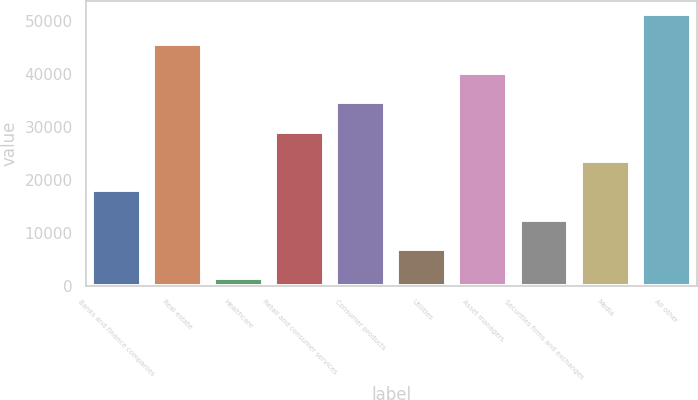<chart> <loc_0><loc_0><loc_500><loc_500><bar_chart><fcel>Banks and finance companies<fcel>Real estate<fcel>Healthcare<fcel>Retail and consumer services<fcel>Consumer products<fcel>Utilities<fcel>Asset managers<fcel>Securities firms and exchanges<fcel>Media<fcel>All other<nl><fcel>18038.6<fcel>45764.6<fcel>1403<fcel>29129<fcel>34674.2<fcel>6948.2<fcel>40219.4<fcel>12493.4<fcel>23583.8<fcel>51309.8<nl></chart> 